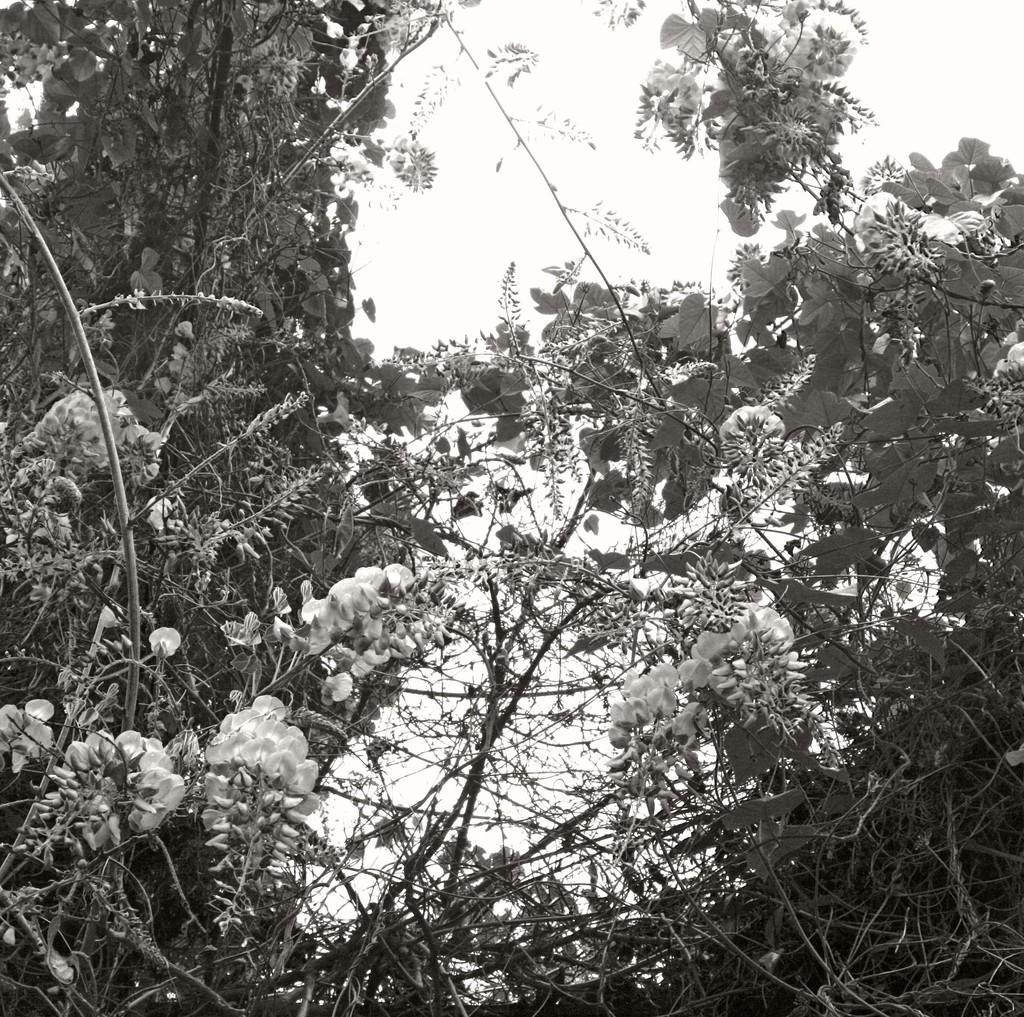Describe this image in one or two sentences. In the image we can see there are lot of trees and the image is in black and white colour. 